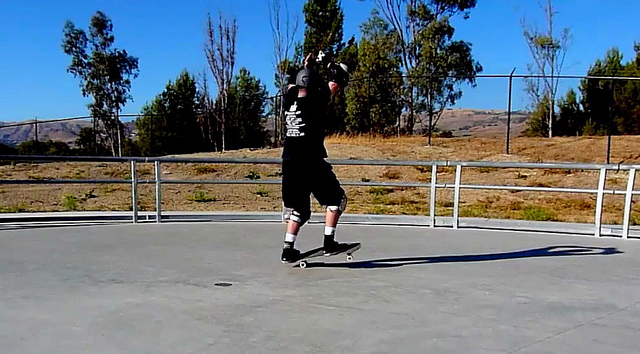Can you describe the man's clothing and gear? The man appears to be wearing a black T-shirt, black shorts, and black sneakers. He also has a helmet, knee pads, and elbow pads, ensuring his safety while performing skateboard tricks. His gear is typical for skaters who prioritize protection while executing challenging maneuvers. Why is protective gear important in skateboarding? Protective gear is crucial in skateboarding as it helps prevent serious injuries during falls or collisions. Helmets protect the head from traumatic brain injuries, knee and elbow pads cushion against fractures and abrasions, and wrist guards stabilize and protect the wrists from sprains and fractures. Given the high impact and dynamic nature of skateboarding tricks, safety gear allows skaters to push their limits while minimizing the risk of injury. Imagine if skateboards were designed to glow in different colors based on the trick performed. Describe how this feature would look. Imagine a skateboard that changes colors dynamically based on the trick being performed! As soon as a skater starts an Ollie, the board might glow a vibrant green, signaling the jump. When transitioning to a Kickflip, the board could shift to a dazzling blue, pulsating as the trick is executed. If a Grind is initiated, the edges of the skateboard could sparkle in silver, mimicking the effect of metal against metal. With Pop Shove-it, a swirling red pattern can emerge, giving the illusion of spinning motion. For Manuals, the board might exhibit a calm, steady yellow glow, representing balance and control. This feature would not only enhance the visual appeal of skateboarding but also allow spectators to better appreciate the complexity and variety of tricks being performed. 